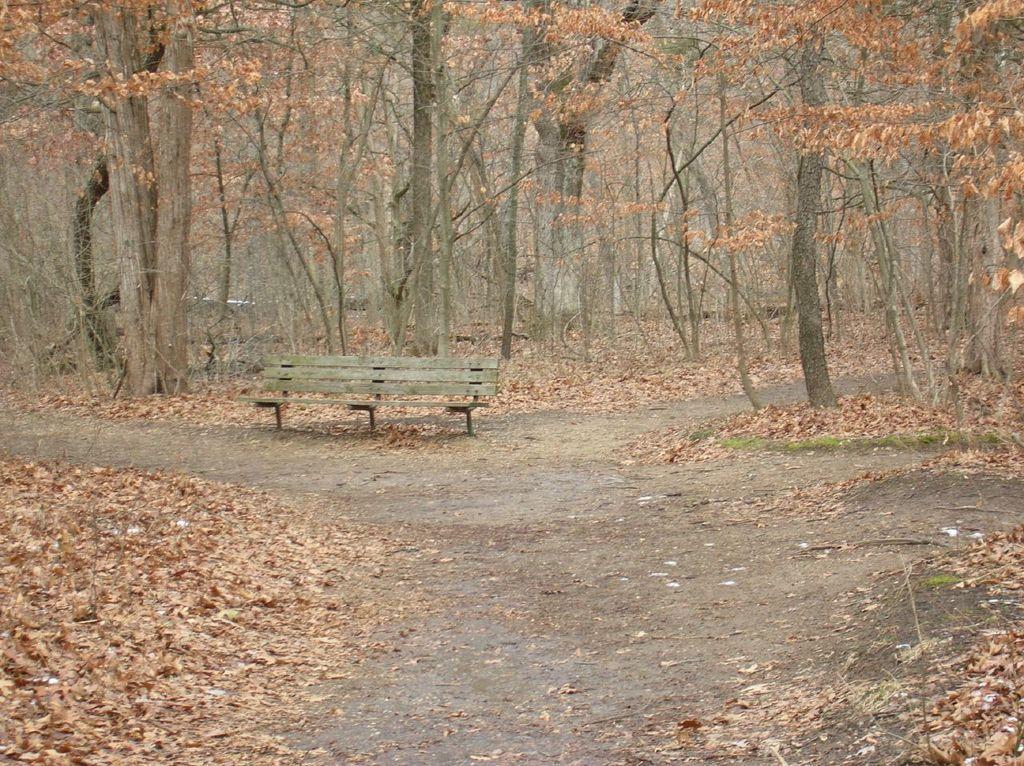How would you summarize this image in a sentence or two? In the center of the image, we can see a bench and in the background, there are trees. At the bottom, there are leaves on the ground. 